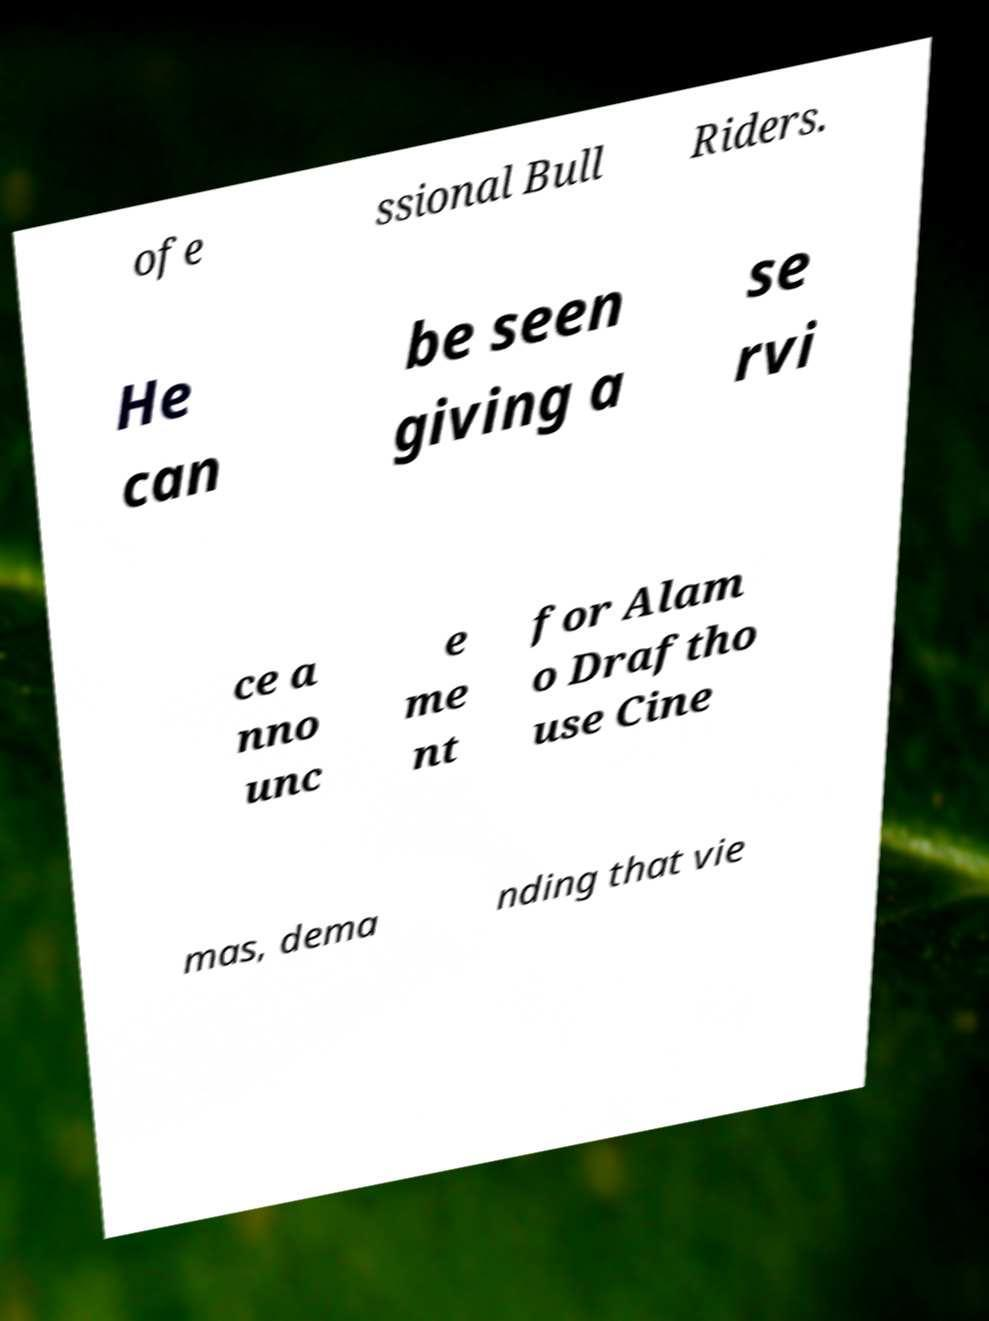There's text embedded in this image that I need extracted. Can you transcribe it verbatim? ofe ssional Bull Riders. He can be seen giving a se rvi ce a nno unc e me nt for Alam o Draftho use Cine mas, dema nding that vie 